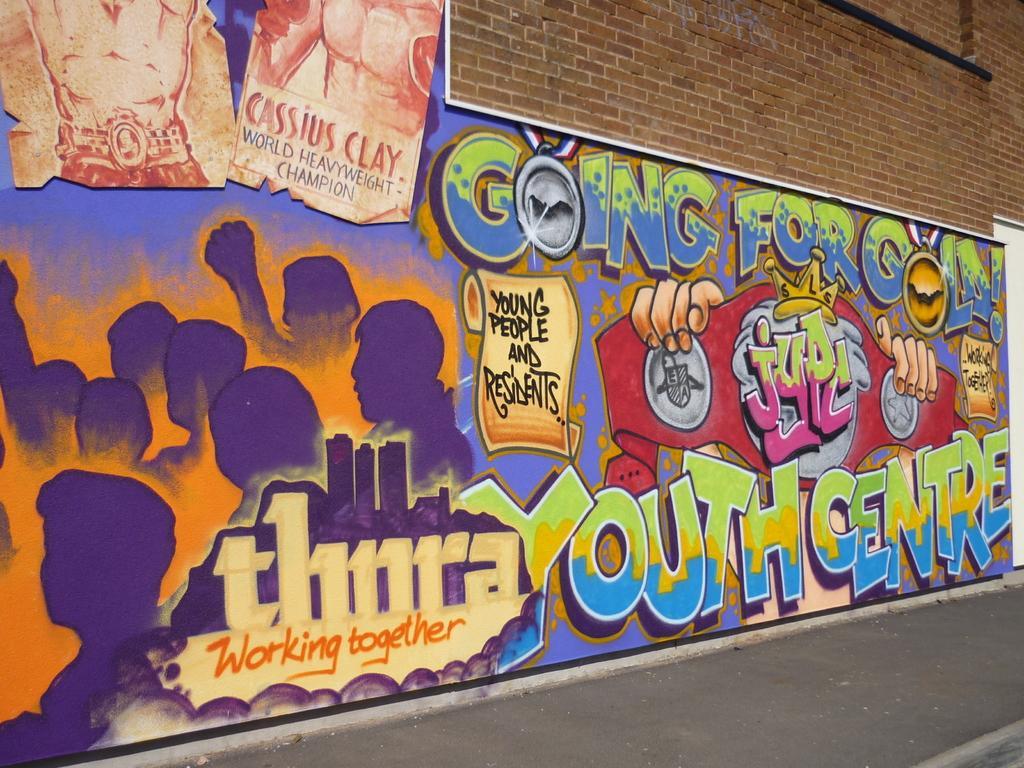Can you describe this image briefly? In this image there is graffiti on a brick wall. 